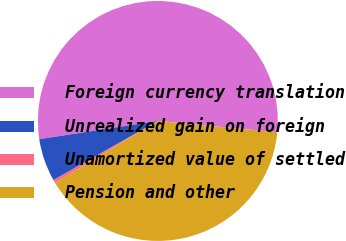<chart> <loc_0><loc_0><loc_500><loc_500><pie_chart><fcel>Foreign currency translation<fcel>Unrealized gain on foreign<fcel>Unamortized value of settled<fcel>Pension and other<nl><fcel>53.93%<fcel>5.78%<fcel>0.43%<fcel>39.86%<nl></chart> 